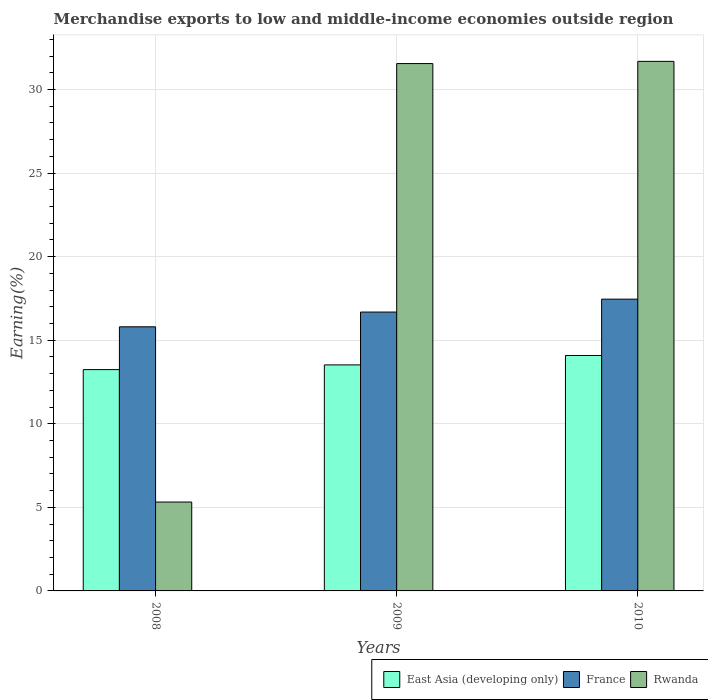How many different coloured bars are there?
Provide a succinct answer. 3. How many bars are there on the 2nd tick from the left?
Your answer should be compact. 3. In how many cases, is the number of bars for a given year not equal to the number of legend labels?
Provide a succinct answer. 0. What is the percentage of amount earned from merchandise exports in France in 2008?
Your answer should be very brief. 15.8. Across all years, what is the maximum percentage of amount earned from merchandise exports in East Asia (developing only)?
Your response must be concise. 14.09. Across all years, what is the minimum percentage of amount earned from merchandise exports in East Asia (developing only)?
Keep it short and to the point. 13.24. In which year was the percentage of amount earned from merchandise exports in France minimum?
Ensure brevity in your answer.  2008. What is the total percentage of amount earned from merchandise exports in Rwanda in the graph?
Offer a very short reply. 68.55. What is the difference between the percentage of amount earned from merchandise exports in Rwanda in 2009 and that in 2010?
Make the answer very short. -0.13. What is the difference between the percentage of amount earned from merchandise exports in East Asia (developing only) in 2008 and the percentage of amount earned from merchandise exports in France in 2009?
Offer a terse response. -3.44. What is the average percentage of amount earned from merchandise exports in East Asia (developing only) per year?
Your answer should be compact. 13.62. In the year 2010, what is the difference between the percentage of amount earned from merchandise exports in East Asia (developing only) and percentage of amount earned from merchandise exports in France?
Offer a terse response. -3.37. What is the ratio of the percentage of amount earned from merchandise exports in France in 2008 to that in 2010?
Ensure brevity in your answer.  0.91. Is the percentage of amount earned from merchandise exports in France in 2008 less than that in 2009?
Your answer should be very brief. Yes. What is the difference between the highest and the second highest percentage of amount earned from merchandise exports in Rwanda?
Your response must be concise. 0.13. What is the difference between the highest and the lowest percentage of amount earned from merchandise exports in Rwanda?
Offer a terse response. 26.37. In how many years, is the percentage of amount earned from merchandise exports in Rwanda greater than the average percentage of amount earned from merchandise exports in Rwanda taken over all years?
Ensure brevity in your answer.  2. What does the 2nd bar from the left in 2008 represents?
Your response must be concise. France. What does the 1st bar from the right in 2008 represents?
Your answer should be compact. Rwanda. Is it the case that in every year, the sum of the percentage of amount earned from merchandise exports in Rwanda and percentage of amount earned from merchandise exports in East Asia (developing only) is greater than the percentage of amount earned from merchandise exports in France?
Offer a terse response. Yes. What is the difference between two consecutive major ticks on the Y-axis?
Your response must be concise. 5. How many legend labels are there?
Your answer should be very brief. 3. How are the legend labels stacked?
Provide a succinct answer. Horizontal. What is the title of the graph?
Your response must be concise. Merchandise exports to low and middle-income economies outside region. Does "Guinea" appear as one of the legend labels in the graph?
Provide a short and direct response. No. What is the label or title of the X-axis?
Your answer should be compact. Years. What is the label or title of the Y-axis?
Ensure brevity in your answer.  Earning(%). What is the Earning(%) in East Asia (developing only) in 2008?
Provide a short and direct response. 13.24. What is the Earning(%) in France in 2008?
Give a very brief answer. 15.8. What is the Earning(%) of Rwanda in 2008?
Your answer should be very brief. 5.32. What is the Earning(%) of East Asia (developing only) in 2009?
Keep it short and to the point. 13.52. What is the Earning(%) of France in 2009?
Provide a short and direct response. 16.68. What is the Earning(%) in Rwanda in 2009?
Your response must be concise. 31.55. What is the Earning(%) of East Asia (developing only) in 2010?
Give a very brief answer. 14.09. What is the Earning(%) of France in 2010?
Offer a very short reply. 17.46. What is the Earning(%) in Rwanda in 2010?
Give a very brief answer. 31.68. Across all years, what is the maximum Earning(%) of East Asia (developing only)?
Your answer should be very brief. 14.09. Across all years, what is the maximum Earning(%) of France?
Ensure brevity in your answer.  17.46. Across all years, what is the maximum Earning(%) of Rwanda?
Offer a very short reply. 31.68. Across all years, what is the minimum Earning(%) of East Asia (developing only)?
Offer a very short reply. 13.24. Across all years, what is the minimum Earning(%) in France?
Offer a very short reply. 15.8. Across all years, what is the minimum Earning(%) of Rwanda?
Offer a very short reply. 5.32. What is the total Earning(%) of East Asia (developing only) in the graph?
Offer a terse response. 40.85. What is the total Earning(%) in France in the graph?
Provide a short and direct response. 49.94. What is the total Earning(%) in Rwanda in the graph?
Provide a short and direct response. 68.55. What is the difference between the Earning(%) in East Asia (developing only) in 2008 and that in 2009?
Offer a very short reply. -0.28. What is the difference between the Earning(%) in France in 2008 and that in 2009?
Your response must be concise. -0.88. What is the difference between the Earning(%) in Rwanda in 2008 and that in 2009?
Ensure brevity in your answer.  -26.23. What is the difference between the Earning(%) in East Asia (developing only) in 2008 and that in 2010?
Your answer should be compact. -0.85. What is the difference between the Earning(%) in France in 2008 and that in 2010?
Make the answer very short. -1.66. What is the difference between the Earning(%) in Rwanda in 2008 and that in 2010?
Ensure brevity in your answer.  -26.37. What is the difference between the Earning(%) of East Asia (developing only) in 2009 and that in 2010?
Provide a short and direct response. -0.56. What is the difference between the Earning(%) in France in 2009 and that in 2010?
Your response must be concise. -0.77. What is the difference between the Earning(%) in Rwanda in 2009 and that in 2010?
Ensure brevity in your answer.  -0.13. What is the difference between the Earning(%) of East Asia (developing only) in 2008 and the Earning(%) of France in 2009?
Offer a very short reply. -3.44. What is the difference between the Earning(%) of East Asia (developing only) in 2008 and the Earning(%) of Rwanda in 2009?
Provide a short and direct response. -18.31. What is the difference between the Earning(%) of France in 2008 and the Earning(%) of Rwanda in 2009?
Ensure brevity in your answer.  -15.75. What is the difference between the Earning(%) of East Asia (developing only) in 2008 and the Earning(%) of France in 2010?
Keep it short and to the point. -4.22. What is the difference between the Earning(%) in East Asia (developing only) in 2008 and the Earning(%) in Rwanda in 2010?
Make the answer very short. -18.44. What is the difference between the Earning(%) in France in 2008 and the Earning(%) in Rwanda in 2010?
Ensure brevity in your answer.  -15.88. What is the difference between the Earning(%) in East Asia (developing only) in 2009 and the Earning(%) in France in 2010?
Offer a very short reply. -3.93. What is the difference between the Earning(%) in East Asia (developing only) in 2009 and the Earning(%) in Rwanda in 2010?
Keep it short and to the point. -18.16. What is the difference between the Earning(%) in France in 2009 and the Earning(%) in Rwanda in 2010?
Provide a succinct answer. -15. What is the average Earning(%) in East Asia (developing only) per year?
Give a very brief answer. 13.62. What is the average Earning(%) of France per year?
Provide a succinct answer. 16.65. What is the average Earning(%) of Rwanda per year?
Keep it short and to the point. 22.85. In the year 2008, what is the difference between the Earning(%) of East Asia (developing only) and Earning(%) of France?
Make the answer very short. -2.56. In the year 2008, what is the difference between the Earning(%) in East Asia (developing only) and Earning(%) in Rwanda?
Make the answer very short. 7.92. In the year 2008, what is the difference between the Earning(%) of France and Earning(%) of Rwanda?
Offer a very short reply. 10.48. In the year 2009, what is the difference between the Earning(%) of East Asia (developing only) and Earning(%) of France?
Provide a succinct answer. -3.16. In the year 2009, what is the difference between the Earning(%) in East Asia (developing only) and Earning(%) in Rwanda?
Your answer should be very brief. -18.03. In the year 2009, what is the difference between the Earning(%) of France and Earning(%) of Rwanda?
Provide a short and direct response. -14.87. In the year 2010, what is the difference between the Earning(%) in East Asia (developing only) and Earning(%) in France?
Provide a succinct answer. -3.37. In the year 2010, what is the difference between the Earning(%) of East Asia (developing only) and Earning(%) of Rwanda?
Your answer should be very brief. -17.6. In the year 2010, what is the difference between the Earning(%) of France and Earning(%) of Rwanda?
Your answer should be very brief. -14.23. What is the ratio of the Earning(%) of East Asia (developing only) in 2008 to that in 2009?
Ensure brevity in your answer.  0.98. What is the ratio of the Earning(%) of France in 2008 to that in 2009?
Offer a very short reply. 0.95. What is the ratio of the Earning(%) of Rwanda in 2008 to that in 2009?
Ensure brevity in your answer.  0.17. What is the ratio of the Earning(%) of East Asia (developing only) in 2008 to that in 2010?
Provide a short and direct response. 0.94. What is the ratio of the Earning(%) of France in 2008 to that in 2010?
Provide a succinct answer. 0.91. What is the ratio of the Earning(%) in Rwanda in 2008 to that in 2010?
Keep it short and to the point. 0.17. What is the ratio of the Earning(%) of France in 2009 to that in 2010?
Offer a terse response. 0.96. What is the ratio of the Earning(%) of Rwanda in 2009 to that in 2010?
Offer a terse response. 1. What is the difference between the highest and the second highest Earning(%) of East Asia (developing only)?
Your answer should be very brief. 0.56. What is the difference between the highest and the second highest Earning(%) of France?
Offer a very short reply. 0.77. What is the difference between the highest and the second highest Earning(%) in Rwanda?
Keep it short and to the point. 0.13. What is the difference between the highest and the lowest Earning(%) in East Asia (developing only)?
Offer a terse response. 0.85. What is the difference between the highest and the lowest Earning(%) in France?
Keep it short and to the point. 1.66. What is the difference between the highest and the lowest Earning(%) of Rwanda?
Provide a short and direct response. 26.37. 